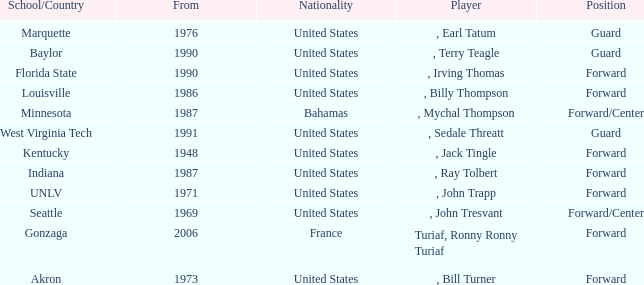What was the nationality of every player that attended Baylor? United States. 